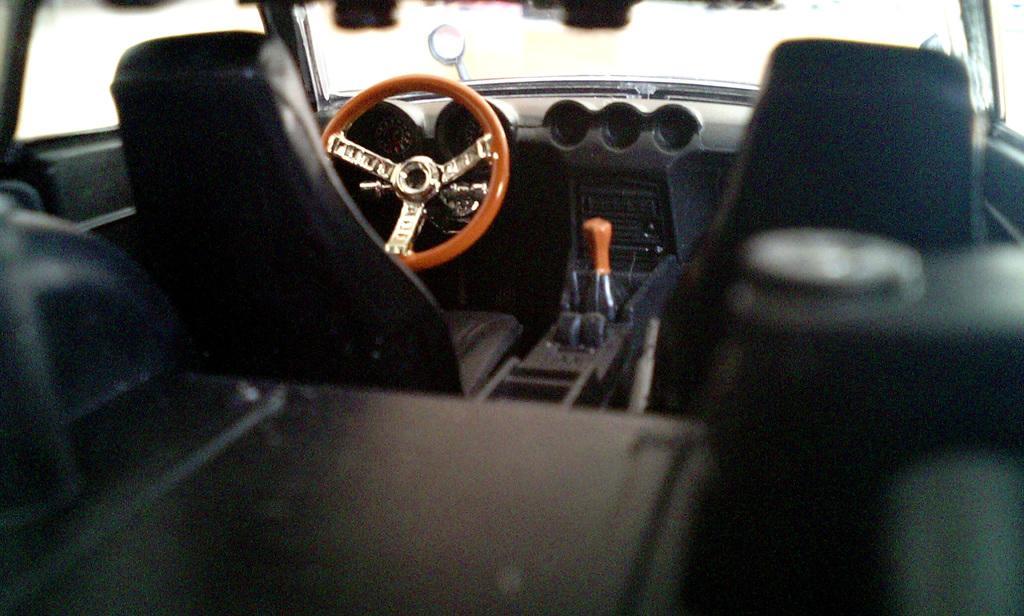In one or two sentences, can you explain what this image depicts? In this image, I can see the inside view of a car. This is a gear stick. I can see the seats. This is a steering wheel. This looks like an auto gauge on the dashboard. At the top of the image, that looks like the glass. 